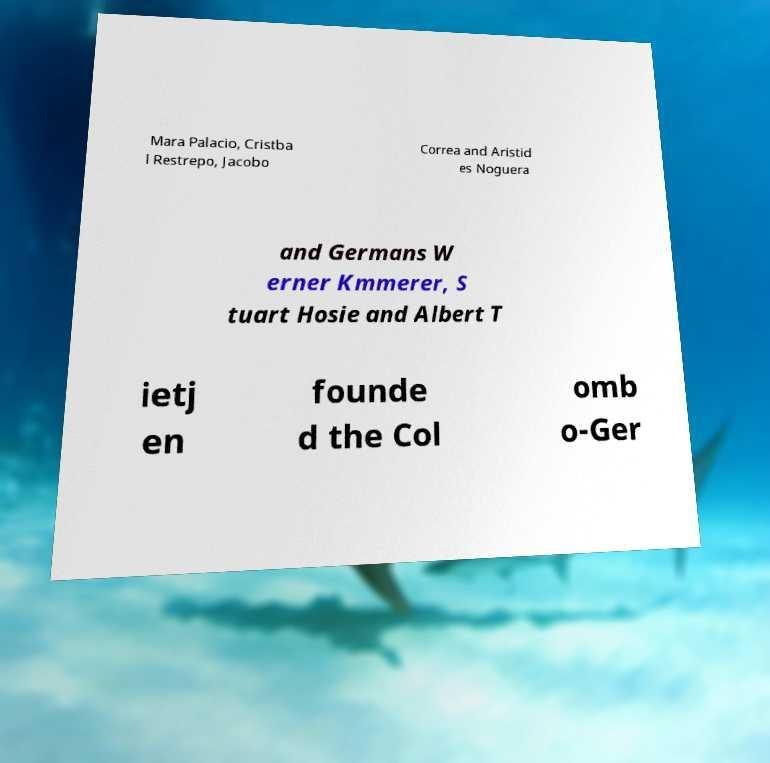Please read and relay the text visible in this image. What does it say? Mara Palacio, Cristba l Restrepo, Jacobo Correa and Aristid es Noguera and Germans W erner Kmmerer, S tuart Hosie and Albert T ietj en founde d the Col omb o-Ger 